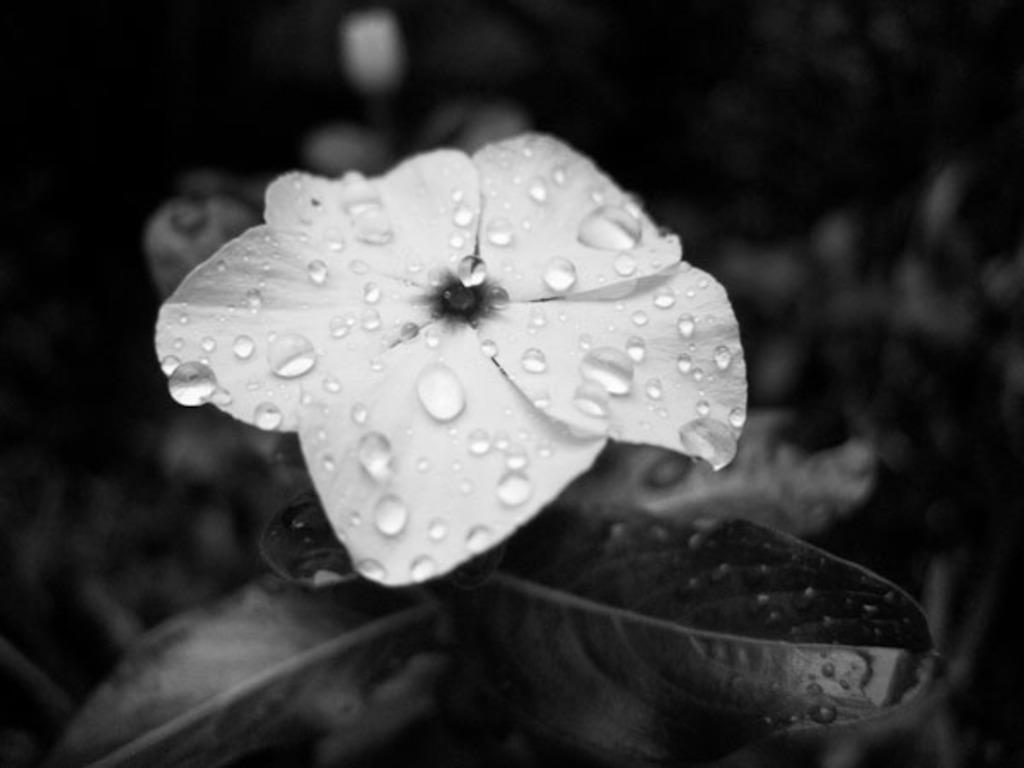What type of living organism is present in the image? There is a plant in the image. What can be observed on the plant? There is a white flower on the plant. Are there any additional details about the flower? Yes, there are water drops on the flower. How would you describe the overall lighting in the image? The image is slightly dark. Can you see the band playing in the background of the image? There is no band present in the image. Is there a ghost visible in the image? There is no ghost present in the image. 